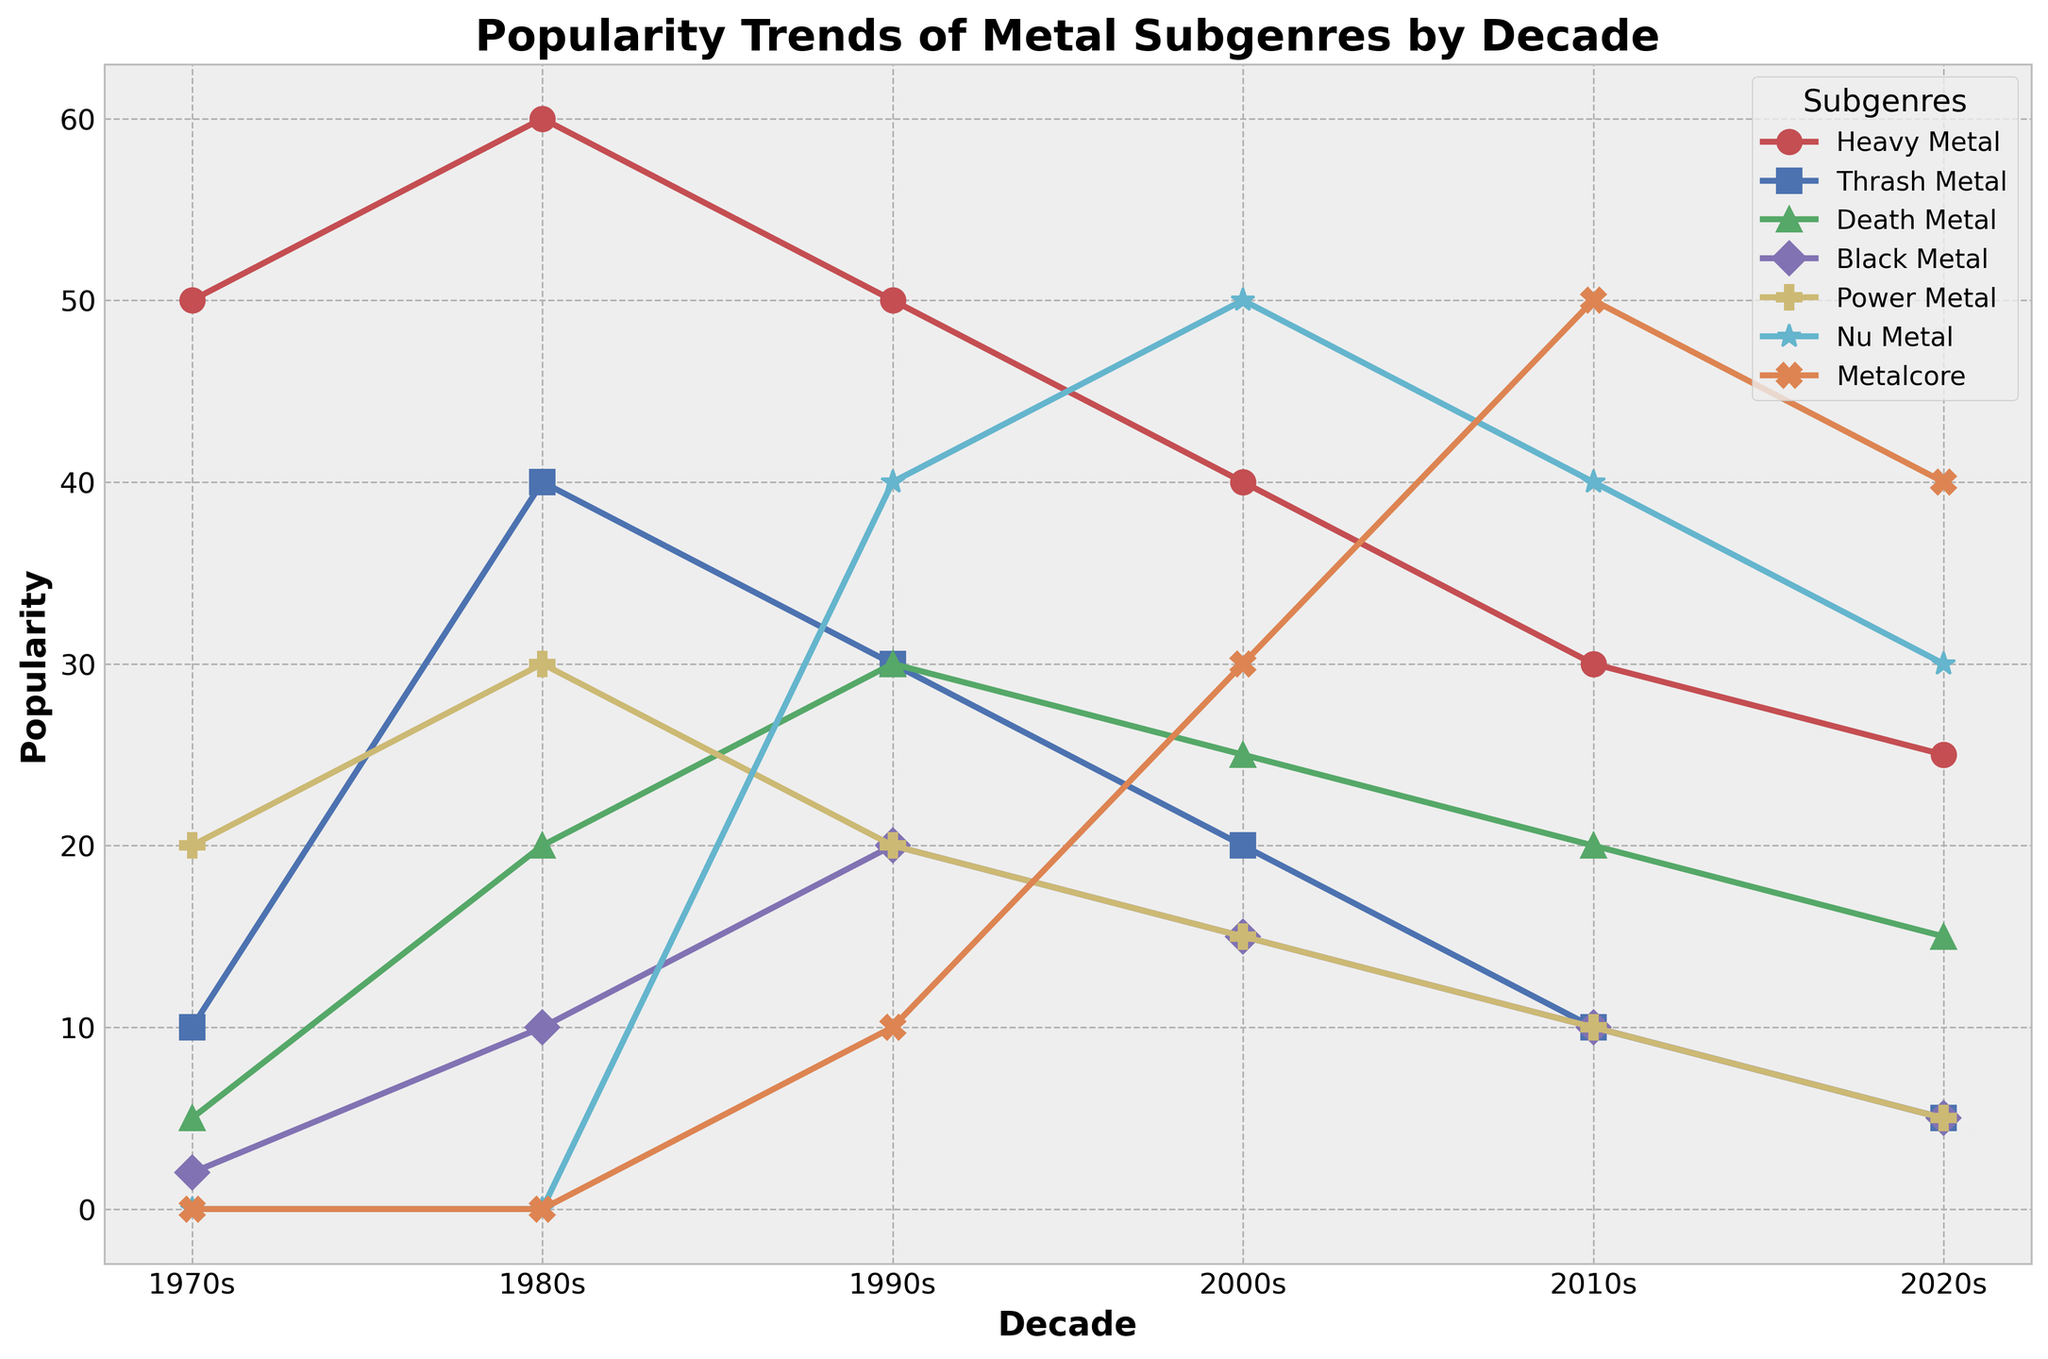Which subgenre had the highest popularity in the 1980s? From the plot, observe that the subgenre with the highest value in the 1980s is Heavy Metal.
Answer: Heavy Metal How did the popularity of Nu Metal change from the 1990s to the 2000s? Check the values for Nu Metal in the 1990s and 2000s. It increased from 40 to 50.
Answer: Increased By how much did Thrash Metal's popularity decrease from the 1980s to the 2000s? Look at the values for Thrash Metal in the 1980s (40) and the 2000s (20). The decrease is 40 - 20 = 20.
Answer: 20 Which decade saw the peak of Death Metal's popularity? Find the highest point for Death Metal on the plot, which occurs in the 1990s with a value of 30.
Answer: 1990s Which subgenre's popularity first appears in the 1990s? Identify the subgenre which has a non-zero value starting in the 1990s. This is Nu Metal with a value of 40.
Answer: Nu Metal What is the total popularity of Power Metal over the decades? Sum the popularity values of Power Metal from all decades: 20 + 30 + 20 + 15 + 10 + 5 = 100.
Answer: 100 Compare the popularity trends of Metalcore and Heavy Metal in the 2010s. Which had higher popularity? Look at the plot for the 2010s values of Metalcore (50) and Heavy Metal (30). Metalcore is higher.
Answer: Metalcore How much did Black Metal's popularity change from the 1970s to the 2010s? Check the values for Black Metal in the 1970s (2) and 2010s (10). The popularity increased by 10 - 2 = 8.
Answer: 8 What visual element differentiates Power Metal's trend line from others? The trend line for Power Metal has a specific color and marker. Power Metal's line is observed to be marked with P and has a distinct color from others.
Answer: Color and marker What is the difference in popularity between Heavy Metal and Nu Metal in the 2020s? Compare the values for Heavy Metal (25) and Nu Metal (30) in the 2020s. The difference is 30 - 25 = 5.
Answer: 5 Which subgenre had the least popularity in the 2000s? Identify the subgenre with the smallest value in the 2000s, which is Thrash Metal at 20.
Answer: Thrash Metal 